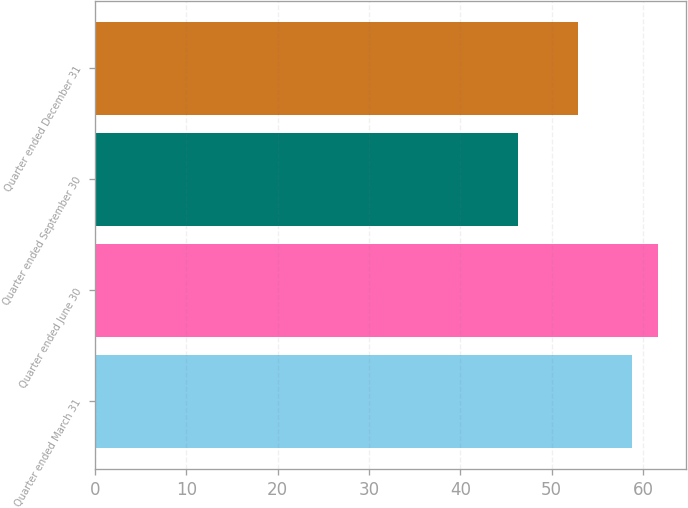Convert chart. <chart><loc_0><loc_0><loc_500><loc_500><bar_chart><fcel>Quarter ended March 31<fcel>Quarter ended June 30<fcel>Quarter ended September 30<fcel>Quarter ended December 31<nl><fcel>58.81<fcel>61.62<fcel>46.35<fcel>52.86<nl></chart> 